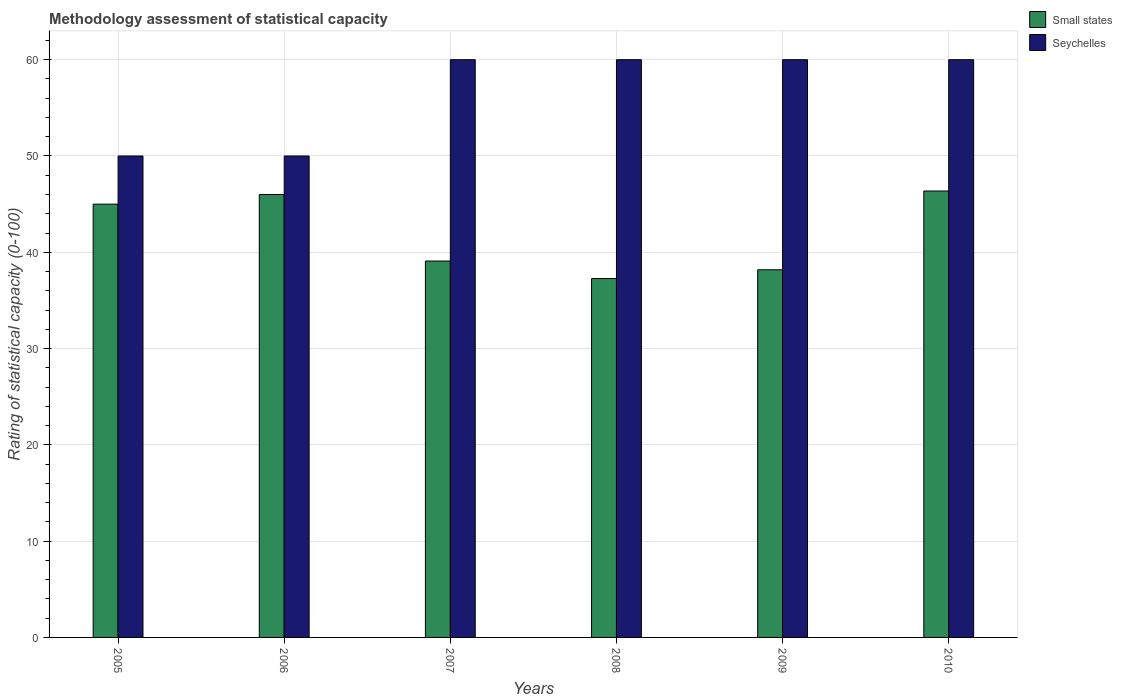How many different coloured bars are there?
Your response must be concise. 2. How many groups of bars are there?
Offer a very short reply. 6. Are the number of bars on each tick of the X-axis equal?
Provide a succinct answer. Yes. How many bars are there on the 5th tick from the right?
Provide a short and direct response. 2. What is the label of the 6th group of bars from the left?
Keep it short and to the point. 2010. Across all years, what is the maximum rating of statistical capacity in Small states?
Provide a succinct answer. 46.36. Across all years, what is the minimum rating of statistical capacity in Small states?
Your answer should be very brief. 37.27. In which year was the rating of statistical capacity in Seychelles maximum?
Provide a short and direct response. 2007. In which year was the rating of statistical capacity in Small states minimum?
Give a very brief answer. 2008. What is the total rating of statistical capacity in Seychelles in the graph?
Offer a terse response. 340. What is the difference between the rating of statistical capacity in Seychelles in 2006 and that in 2010?
Keep it short and to the point. -10. What is the difference between the rating of statistical capacity in Seychelles in 2007 and the rating of statistical capacity in Small states in 2009?
Ensure brevity in your answer.  21.82. What is the average rating of statistical capacity in Small states per year?
Your answer should be compact. 41.98. In the year 2008, what is the difference between the rating of statistical capacity in Small states and rating of statistical capacity in Seychelles?
Your answer should be compact. -22.73. In how many years, is the rating of statistical capacity in Seychelles greater than 2?
Provide a succinct answer. 6. What is the ratio of the rating of statistical capacity in Seychelles in 2008 to that in 2010?
Offer a very short reply. 1. What is the difference between the highest and the second highest rating of statistical capacity in Seychelles?
Provide a succinct answer. 0. In how many years, is the rating of statistical capacity in Small states greater than the average rating of statistical capacity in Small states taken over all years?
Your answer should be very brief. 3. What does the 1st bar from the left in 2010 represents?
Keep it short and to the point. Small states. What does the 2nd bar from the right in 2007 represents?
Provide a short and direct response. Small states. Are all the bars in the graph horizontal?
Your answer should be very brief. No. What is the difference between two consecutive major ticks on the Y-axis?
Give a very brief answer. 10. Are the values on the major ticks of Y-axis written in scientific E-notation?
Offer a very short reply. No. Does the graph contain any zero values?
Your answer should be very brief. No. How are the legend labels stacked?
Make the answer very short. Vertical. What is the title of the graph?
Your answer should be compact. Methodology assessment of statistical capacity. What is the label or title of the Y-axis?
Offer a very short reply. Rating of statistical capacity (0-100). What is the Rating of statistical capacity (0-100) of Small states in 2006?
Ensure brevity in your answer.  46. What is the Rating of statistical capacity (0-100) in Small states in 2007?
Give a very brief answer. 39.09. What is the Rating of statistical capacity (0-100) in Seychelles in 2007?
Offer a terse response. 60. What is the Rating of statistical capacity (0-100) in Small states in 2008?
Provide a succinct answer. 37.27. What is the Rating of statistical capacity (0-100) in Small states in 2009?
Your answer should be very brief. 38.18. What is the Rating of statistical capacity (0-100) in Seychelles in 2009?
Your answer should be compact. 60. What is the Rating of statistical capacity (0-100) of Small states in 2010?
Your answer should be compact. 46.36. Across all years, what is the maximum Rating of statistical capacity (0-100) in Small states?
Ensure brevity in your answer.  46.36. Across all years, what is the minimum Rating of statistical capacity (0-100) of Small states?
Keep it short and to the point. 37.27. What is the total Rating of statistical capacity (0-100) in Small states in the graph?
Provide a succinct answer. 251.91. What is the total Rating of statistical capacity (0-100) of Seychelles in the graph?
Offer a terse response. 340. What is the difference between the Rating of statistical capacity (0-100) of Small states in 2005 and that in 2006?
Ensure brevity in your answer.  -1. What is the difference between the Rating of statistical capacity (0-100) of Seychelles in 2005 and that in 2006?
Keep it short and to the point. 0. What is the difference between the Rating of statistical capacity (0-100) in Small states in 2005 and that in 2007?
Offer a terse response. 5.91. What is the difference between the Rating of statistical capacity (0-100) of Small states in 2005 and that in 2008?
Offer a terse response. 7.73. What is the difference between the Rating of statistical capacity (0-100) of Seychelles in 2005 and that in 2008?
Keep it short and to the point. -10. What is the difference between the Rating of statistical capacity (0-100) of Small states in 2005 and that in 2009?
Provide a succinct answer. 6.82. What is the difference between the Rating of statistical capacity (0-100) in Small states in 2005 and that in 2010?
Offer a terse response. -1.36. What is the difference between the Rating of statistical capacity (0-100) of Seychelles in 2005 and that in 2010?
Make the answer very short. -10. What is the difference between the Rating of statistical capacity (0-100) of Small states in 2006 and that in 2007?
Ensure brevity in your answer.  6.91. What is the difference between the Rating of statistical capacity (0-100) of Seychelles in 2006 and that in 2007?
Give a very brief answer. -10. What is the difference between the Rating of statistical capacity (0-100) in Small states in 2006 and that in 2008?
Your answer should be compact. 8.73. What is the difference between the Rating of statistical capacity (0-100) in Small states in 2006 and that in 2009?
Provide a succinct answer. 7.82. What is the difference between the Rating of statistical capacity (0-100) of Seychelles in 2006 and that in 2009?
Offer a terse response. -10. What is the difference between the Rating of statistical capacity (0-100) in Small states in 2006 and that in 2010?
Make the answer very short. -0.36. What is the difference between the Rating of statistical capacity (0-100) of Small states in 2007 and that in 2008?
Provide a short and direct response. 1.82. What is the difference between the Rating of statistical capacity (0-100) of Seychelles in 2007 and that in 2008?
Make the answer very short. 0. What is the difference between the Rating of statistical capacity (0-100) in Small states in 2007 and that in 2009?
Provide a succinct answer. 0.91. What is the difference between the Rating of statistical capacity (0-100) of Seychelles in 2007 and that in 2009?
Provide a succinct answer. 0. What is the difference between the Rating of statistical capacity (0-100) of Small states in 2007 and that in 2010?
Give a very brief answer. -7.27. What is the difference between the Rating of statistical capacity (0-100) of Seychelles in 2007 and that in 2010?
Your answer should be very brief. 0. What is the difference between the Rating of statistical capacity (0-100) of Small states in 2008 and that in 2009?
Provide a short and direct response. -0.91. What is the difference between the Rating of statistical capacity (0-100) of Small states in 2008 and that in 2010?
Provide a short and direct response. -9.09. What is the difference between the Rating of statistical capacity (0-100) in Seychelles in 2008 and that in 2010?
Provide a succinct answer. 0. What is the difference between the Rating of statistical capacity (0-100) in Small states in 2009 and that in 2010?
Provide a succinct answer. -8.18. What is the difference between the Rating of statistical capacity (0-100) in Seychelles in 2009 and that in 2010?
Your answer should be very brief. 0. What is the difference between the Rating of statistical capacity (0-100) in Small states in 2005 and the Rating of statistical capacity (0-100) in Seychelles in 2006?
Make the answer very short. -5. What is the difference between the Rating of statistical capacity (0-100) in Small states in 2005 and the Rating of statistical capacity (0-100) in Seychelles in 2007?
Keep it short and to the point. -15. What is the difference between the Rating of statistical capacity (0-100) of Small states in 2005 and the Rating of statistical capacity (0-100) of Seychelles in 2010?
Make the answer very short. -15. What is the difference between the Rating of statistical capacity (0-100) of Small states in 2006 and the Rating of statistical capacity (0-100) of Seychelles in 2007?
Offer a very short reply. -14. What is the difference between the Rating of statistical capacity (0-100) of Small states in 2007 and the Rating of statistical capacity (0-100) of Seychelles in 2008?
Make the answer very short. -20.91. What is the difference between the Rating of statistical capacity (0-100) in Small states in 2007 and the Rating of statistical capacity (0-100) in Seychelles in 2009?
Provide a succinct answer. -20.91. What is the difference between the Rating of statistical capacity (0-100) of Small states in 2007 and the Rating of statistical capacity (0-100) of Seychelles in 2010?
Your answer should be compact. -20.91. What is the difference between the Rating of statistical capacity (0-100) in Small states in 2008 and the Rating of statistical capacity (0-100) in Seychelles in 2009?
Provide a short and direct response. -22.73. What is the difference between the Rating of statistical capacity (0-100) of Small states in 2008 and the Rating of statistical capacity (0-100) of Seychelles in 2010?
Offer a terse response. -22.73. What is the difference between the Rating of statistical capacity (0-100) in Small states in 2009 and the Rating of statistical capacity (0-100) in Seychelles in 2010?
Your answer should be very brief. -21.82. What is the average Rating of statistical capacity (0-100) of Small states per year?
Your response must be concise. 41.98. What is the average Rating of statistical capacity (0-100) of Seychelles per year?
Offer a very short reply. 56.67. In the year 2006, what is the difference between the Rating of statistical capacity (0-100) of Small states and Rating of statistical capacity (0-100) of Seychelles?
Provide a short and direct response. -4. In the year 2007, what is the difference between the Rating of statistical capacity (0-100) of Small states and Rating of statistical capacity (0-100) of Seychelles?
Make the answer very short. -20.91. In the year 2008, what is the difference between the Rating of statistical capacity (0-100) of Small states and Rating of statistical capacity (0-100) of Seychelles?
Provide a succinct answer. -22.73. In the year 2009, what is the difference between the Rating of statistical capacity (0-100) of Small states and Rating of statistical capacity (0-100) of Seychelles?
Your answer should be compact. -21.82. In the year 2010, what is the difference between the Rating of statistical capacity (0-100) in Small states and Rating of statistical capacity (0-100) in Seychelles?
Provide a succinct answer. -13.64. What is the ratio of the Rating of statistical capacity (0-100) of Small states in 2005 to that in 2006?
Your response must be concise. 0.98. What is the ratio of the Rating of statistical capacity (0-100) in Seychelles in 2005 to that in 2006?
Your answer should be very brief. 1. What is the ratio of the Rating of statistical capacity (0-100) of Small states in 2005 to that in 2007?
Provide a succinct answer. 1.15. What is the ratio of the Rating of statistical capacity (0-100) of Seychelles in 2005 to that in 2007?
Your answer should be compact. 0.83. What is the ratio of the Rating of statistical capacity (0-100) in Small states in 2005 to that in 2008?
Make the answer very short. 1.21. What is the ratio of the Rating of statistical capacity (0-100) in Small states in 2005 to that in 2009?
Provide a short and direct response. 1.18. What is the ratio of the Rating of statistical capacity (0-100) of Small states in 2005 to that in 2010?
Your answer should be very brief. 0.97. What is the ratio of the Rating of statistical capacity (0-100) of Small states in 2006 to that in 2007?
Your answer should be very brief. 1.18. What is the ratio of the Rating of statistical capacity (0-100) of Small states in 2006 to that in 2008?
Ensure brevity in your answer.  1.23. What is the ratio of the Rating of statistical capacity (0-100) in Small states in 2006 to that in 2009?
Make the answer very short. 1.2. What is the ratio of the Rating of statistical capacity (0-100) of Seychelles in 2006 to that in 2009?
Keep it short and to the point. 0.83. What is the ratio of the Rating of statistical capacity (0-100) in Small states in 2007 to that in 2008?
Offer a terse response. 1.05. What is the ratio of the Rating of statistical capacity (0-100) of Small states in 2007 to that in 2009?
Give a very brief answer. 1.02. What is the ratio of the Rating of statistical capacity (0-100) of Small states in 2007 to that in 2010?
Make the answer very short. 0.84. What is the ratio of the Rating of statistical capacity (0-100) in Seychelles in 2007 to that in 2010?
Provide a succinct answer. 1. What is the ratio of the Rating of statistical capacity (0-100) of Small states in 2008 to that in 2009?
Offer a terse response. 0.98. What is the ratio of the Rating of statistical capacity (0-100) of Seychelles in 2008 to that in 2009?
Provide a succinct answer. 1. What is the ratio of the Rating of statistical capacity (0-100) in Small states in 2008 to that in 2010?
Your answer should be very brief. 0.8. What is the ratio of the Rating of statistical capacity (0-100) of Seychelles in 2008 to that in 2010?
Provide a succinct answer. 1. What is the ratio of the Rating of statistical capacity (0-100) in Small states in 2009 to that in 2010?
Keep it short and to the point. 0.82. What is the difference between the highest and the second highest Rating of statistical capacity (0-100) in Small states?
Make the answer very short. 0.36. What is the difference between the highest and the second highest Rating of statistical capacity (0-100) of Seychelles?
Make the answer very short. 0. What is the difference between the highest and the lowest Rating of statistical capacity (0-100) in Small states?
Keep it short and to the point. 9.09. What is the difference between the highest and the lowest Rating of statistical capacity (0-100) in Seychelles?
Make the answer very short. 10. 